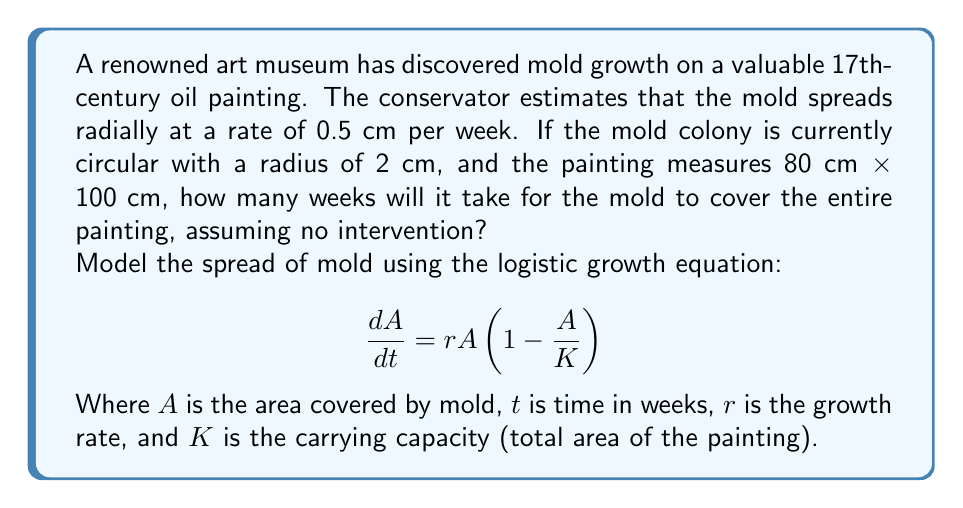Give your solution to this math problem. To solve this problem, we'll follow these steps:

1. Calculate the initial area of the mold and the total area of the painting.
2. Determine the growth rate $r$ based on the given radial spread.
3. Solve the logistic growth equation to find the time when the mold covers the entire painting.

Step 1: Calculate areas
- Initial mold area: $A_0 = \pi r^2 = \pi (2 \text{ cm})^2 = 4\pi \text{ cm}^2$
- Total painting area: $K = 80 \text{ cm} \times 100 \text{ cm} = 8000 \text{ cm}^2$

Step 2: Determine growth rate
The radial growth rate is 0.5 cm/week. To convert this to area growth:
$r = 2 \times 0.5 \text{ cm/week} \times 2\pi = 2\pi \text{ cm}^2/\text{week}$

Step 3: Solve the logistic growth equation
The solution to the logistic growth equation is:

$$A(t) = \frac{K}{1 + (\frac{K}{A_0} - 1)e^{-rt}}$$

We want to find $t$ when $A(t) = K$. Substituting and solving:

$$K = \frac{K}{1 + (\frac{K}{A_0} - 1)e^{-rt}}$$

$$1 = \frac{1}{1 + (\frac{K}{A_0} - 1)e^{-rt}}$$

$$(\frac{K}{A_0} - 1)e^{-rt} = 0$$

$$e^{-rt} = 0$$

This equation is satisfied when $t$ approaches infinity. However, we can consider the painting "fully covered" when the mold area reaches 99% of the total area. So, we solve:

$$0.99K = \frac{K}{1 + (\frac{K}{A_0} - 1)e^{-rt}}$$

Solving for $t$:

$$t = \frac{1}{r} \ln\left(\frac{K/A_0 - 1}{1/0.99 - 1}\right)$$

Substituting the values:

$$t = \frac{1}{2\pi} \ln\left(\frac{8000/(4\pi) - 1}{1/0.99 - 1}\right) \approx 10.86 \text{ weeks}$$
Answer: It will take approximately 11 weeks for the mold to cover 99% of the painting. 